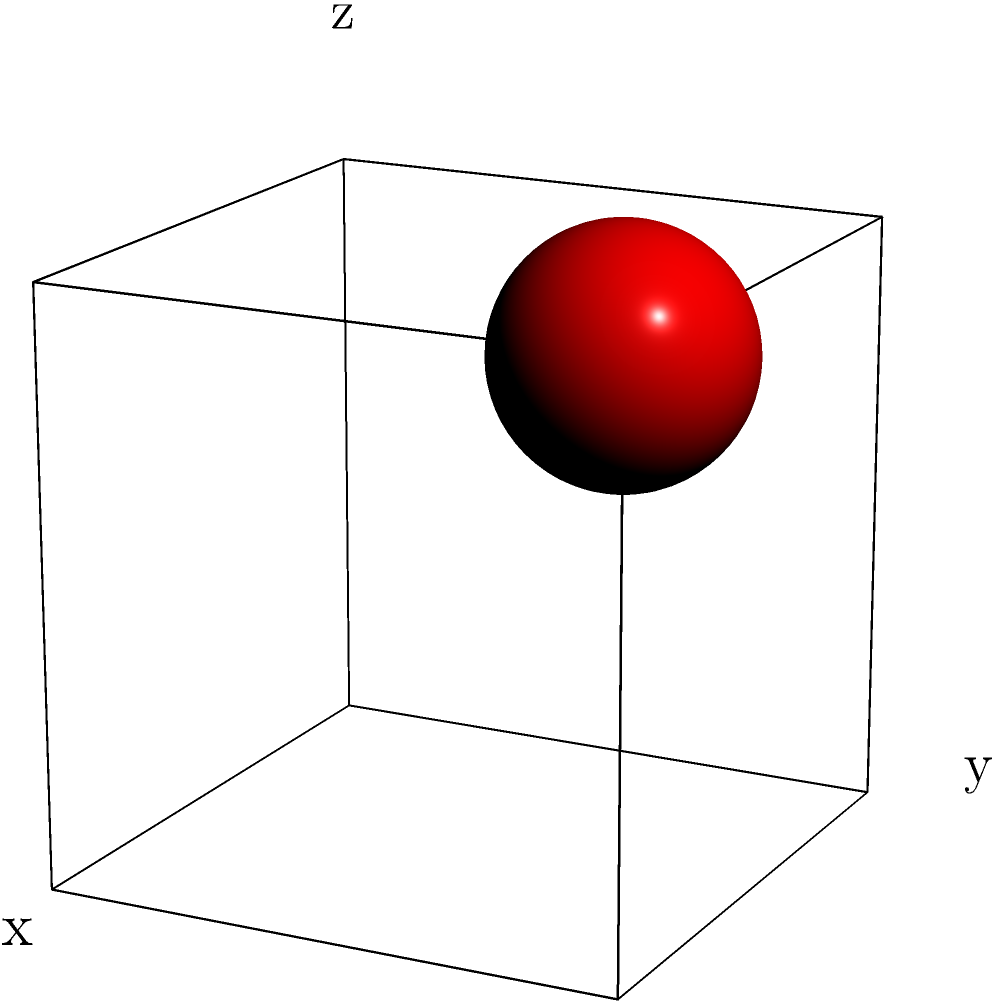Describe the appearance of the 3D model when viewed from directly above (bird's-eye view). How would the positioning of the red sphere change in relation to the cube from this perspective? To visualize this 3D model from a bird's-eye view, we need to mentally rotate the image so that we're looking down on it from above. Let's break this down step-by-step:

1. The model consists of a cube with a small red sphere attached to one of its corners.

2. When viewed from directly above:
   a. The cube will appear as a square, as we're looking down on its top face.
   b. The edges of the cube that were vertical (along the z-axis) will not be visible.
   c. The top face of the cube will be fully visible, while the side faces will be hidden.

3. The red sphere is positioned at the top right corner of the cube in the current view.

4. When rotated to a bird's-eye view:
   a. The red sphere will remain at a corner of the square (cube's top face).
   b. It will appear in the bottom right corner of the square.

5. The change in the sphere's position is due to the rotation of our perspective:
   a. What was the "top" of the cube becomes the side facing us.
   b. The corner where the sphere is attached doesn't move, but our view of it changes.

6. From this new perspective, the sphere will appear to be sitting on top of the corner of the square, rather than being attached to the side as in the original view.
Answer: Square with red sphere at bottom right corner 